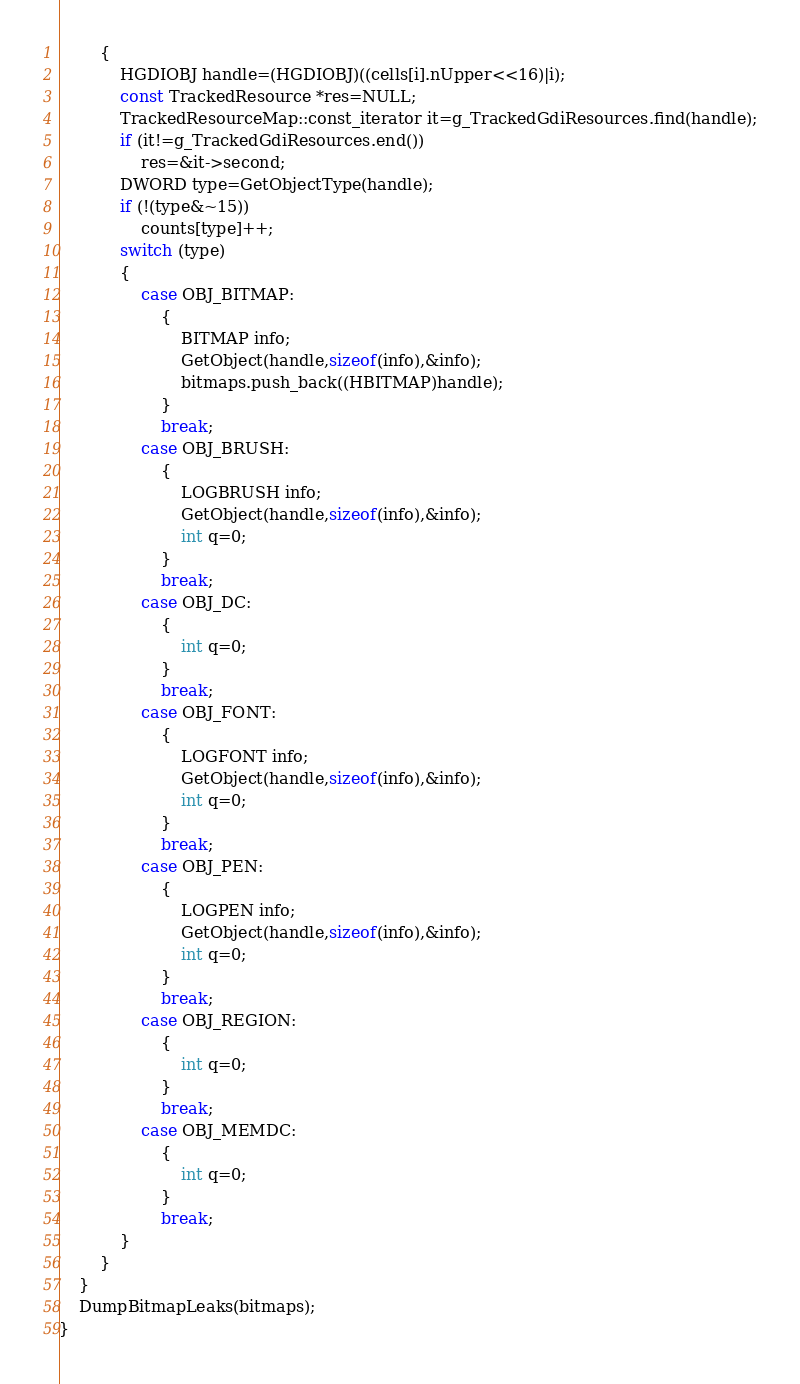<code> <loc_0><loc_0><loc_500><loc_500><_C++_>		{
			HGDIOBJ handle=(HGDIOBJ)((cells[i].nUpper<<16)|i);
			const TrackedResource *res=NULL;
			TrackedResourceMap::const_iterator it=g_TrackedGdiResources.find(handle);
			if (it!=g_TrackedGdiResources.end())
				res=&it->second;
			DWORD type=GetObjectType(handle);
			if (!(type&~15))
				counts[type]++;
			switch (type)
			{
				case OBJ_BITMAP:
					{
						BITMAP info;
						GetObject(handle,sizeof(info),&info);
						bitmaps.push_back((HBITMAP)handle);
					}
					break;
				case OBJ_BRUSH:
					{
						LOGBRUSH info;
						GetObject(handle,sizeof(info),&info);
						int q=0;
					}
					break;
				case OBJ_DC:
					{
						int q=0;
					}
					break;
				case OBJ_FONT:
					{
						LOGFONT info;
						GetObject(handle,sizeof(info),&info);
						int q=0;
					}
					break;
				case OBJ_PEN:
					{
						LOGPEN info;
						GetObject(handle,sizeof(info),&info);
						int q=0;
					}
					break;
				case OBJ_REGION:
					{
						int q=0;
					}
					break;
				case OBJ_MEMDC:
					{
						int q=0;
					}
					break;
			}
		}
	}
	DumpBitmapLeaks(bitmaps);
}
</code> 